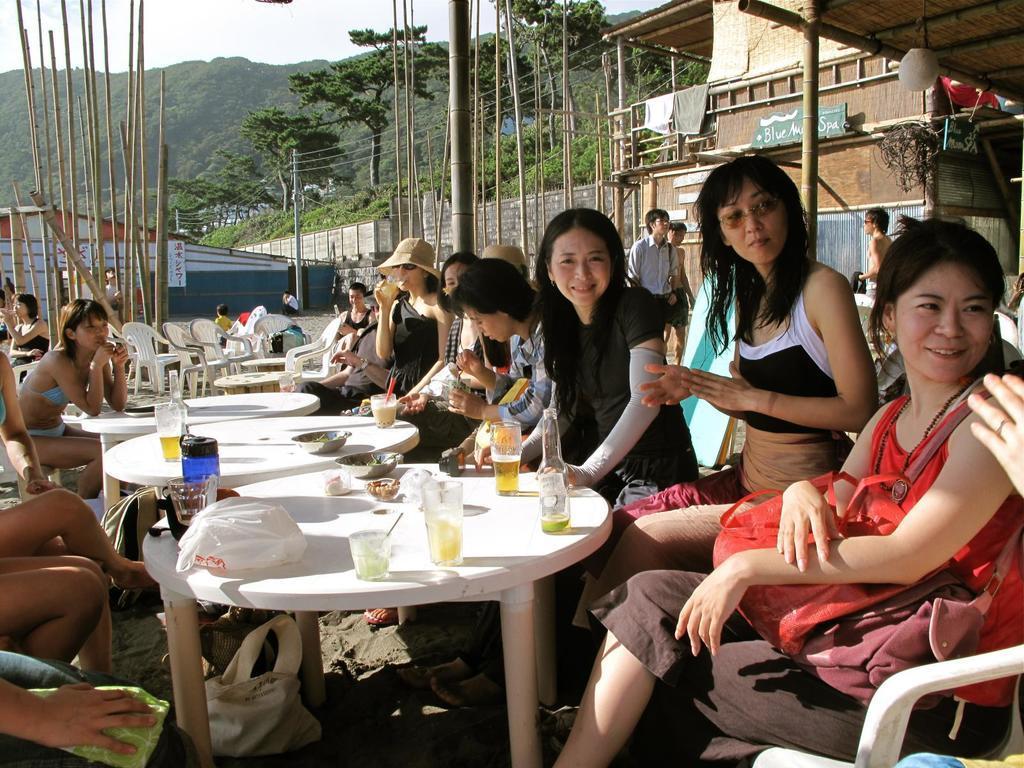Could you give a brief overview of what you see in this image? Here we can see a group of people are sitting on the chair, and in front here is the table and glasses and some objects on it, and here are the trees, and here are the bamboo sticks. 